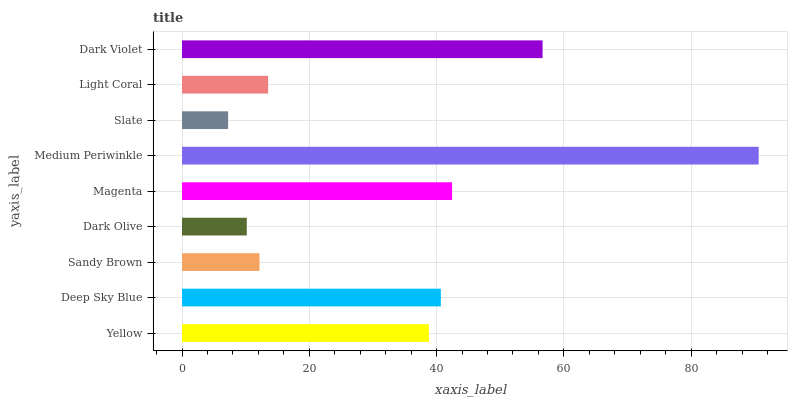Is Slate the minimum?
Answer yes or no. Yes. Is Medium Periwinkle the maximum?
Answer yes or no. Yes. Is Deep Sky Blue the minimum?
Answer yes or no. No. Is Deep Sky Blue the maximum?
Answer yes or no. No. Is Deep Sky Blue greater than Yellow?
Answer yes or no. Yes. Is Yellow less than Deep Sky Blue?
Answer yes or no. Yes. Is Yellow greater than Deep Sky Blue?
Answer yes or no. No. Is Deep Sky Blue less than Yellow?
Answer yes or no. No. Is Yellow the high median?
Answer yes or no. Yes. Is Yellow the low median?
Answer yes or no. Yes. Is Dark Olive the high median?
Answer yes or no. No. Is Dark Violet the low median?
Answer yes or no. No. 